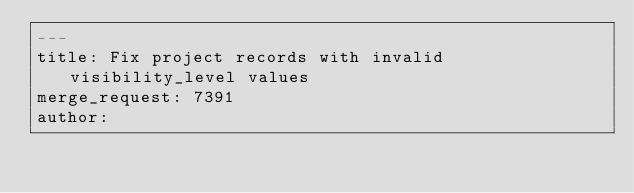<code> <loc_0><loc_0><loc_500><loc_500><_YAML_>---
title: Fix project records with invalid visibility_level values
merge_request: 7391
author: 
</code> 